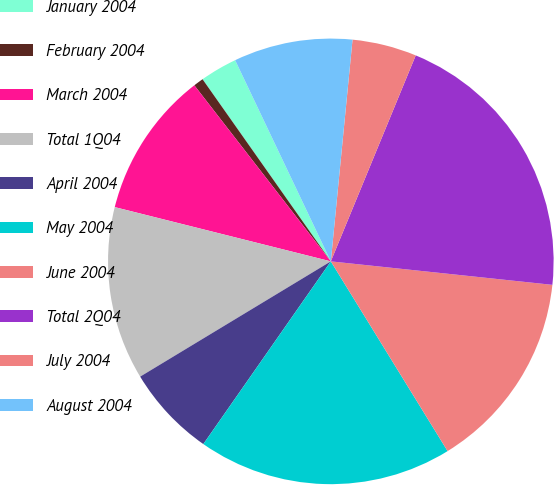Convert chart to OTSL. <chart><loc_0><loc_0><loc_500><loc_500><pie_chart><fcel>January 2004<fcel>February 2004<fcel>March 2004<fcel>Total 1Q04<fcel>April 2004<fcel>May 2004<fcel>June 2004<fcel>Total 2Q04<fcel>July 2004<fcel>August 2004<nl><fcel>2.7%<fcel>0.73%<fcel>10.59%<fcel>12.57%<fcel>6.65%<fcel>18.48%<fcel>14.54%<fcel>20.46%<fcel>4.67%<fcel>8.62%<nl></chart> 